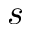<formula> <loc_0><loc_0><loc_500><loc_500>s ^ { \ t h }</formula> 